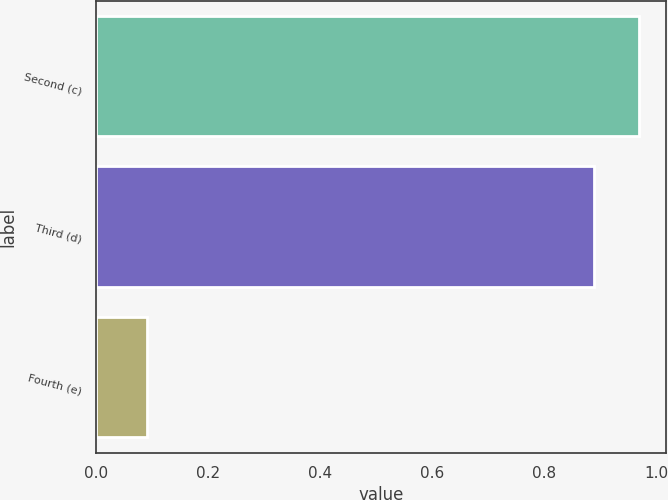Convert chart. <chart><loc_0><loc_0><loc_500><loc_500><bar_chart><fcel>Second (c)<fcel>Third (d)<fcel>Fourth (e)<nl><fcel>0.97<fcel>0.89<fcel>0.09<nl></chart> 